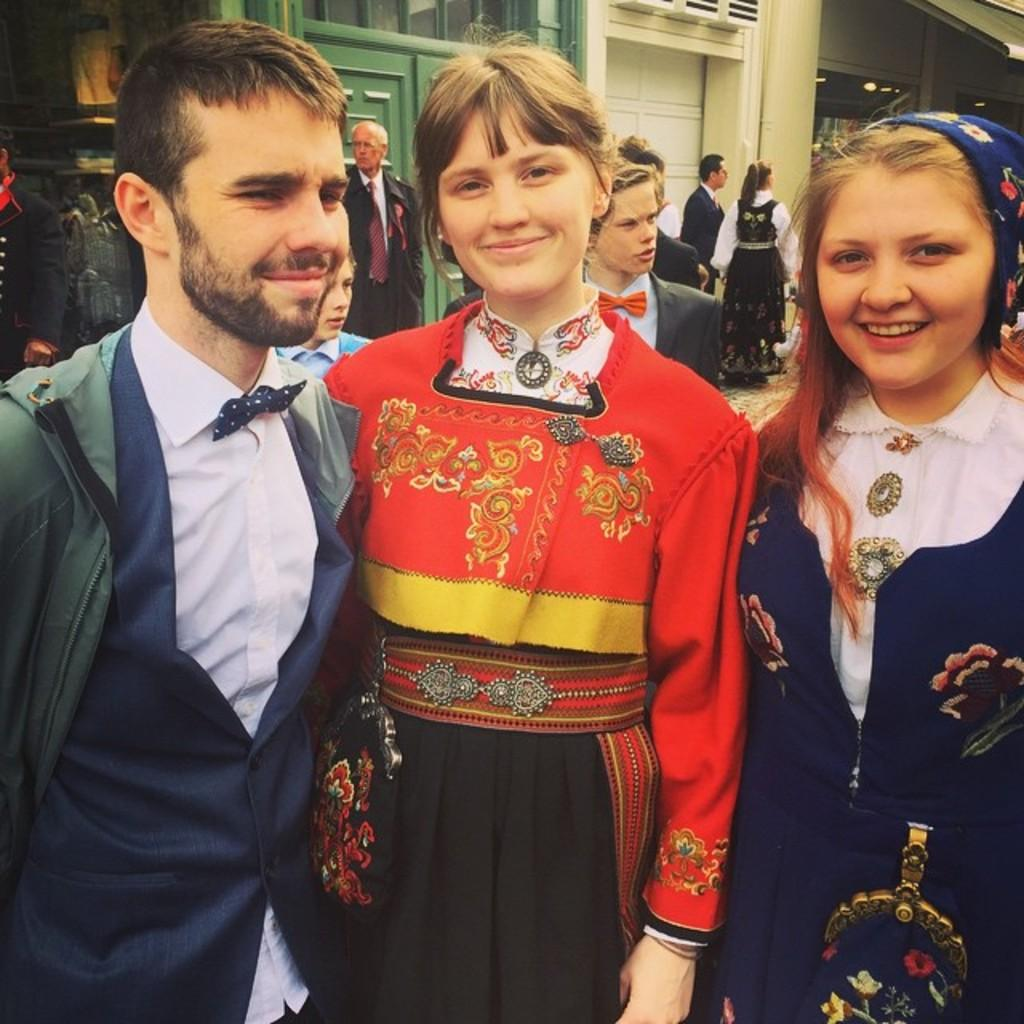How many people are in the image? There are two ladies and a man in the image, making a total of three people. What are the people in the image doing? The people are standing and posing for a photograph. Can you describe the background of the image? There are people and buildings in the background of the image. Are there any boats visible in the image? No, there are no boats present in the image. What season is depicted in the image? The provided facts do not mention any seasonal details, so it cannot be determined from the image. 